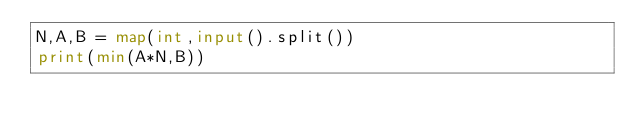Convert code to text. <code><loc_0><loc_0><loc_500><loc_500><_Python_>N,A,B = map(int,input().split())
print(min(A*N,B))</code> 